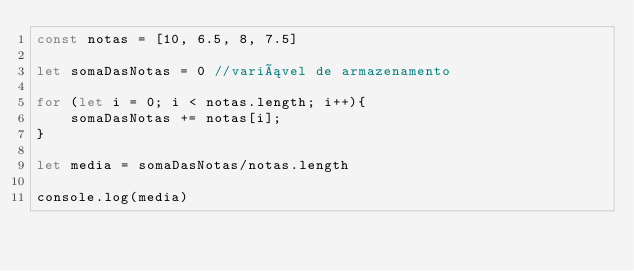Convert code to text. <code><loc_0><loc_0><loc_500><loc_500><_JavaScript_>const notas = [10, 6.5, 8, 7.5]

let somaDasNotas = 0 //variável de armazenamento

for (let i = 0; i < notas.length; i++){
    somaDasNotas += notas[i];
}

let media = somaDasNotas/notas.length

console.log(media)
</code> 